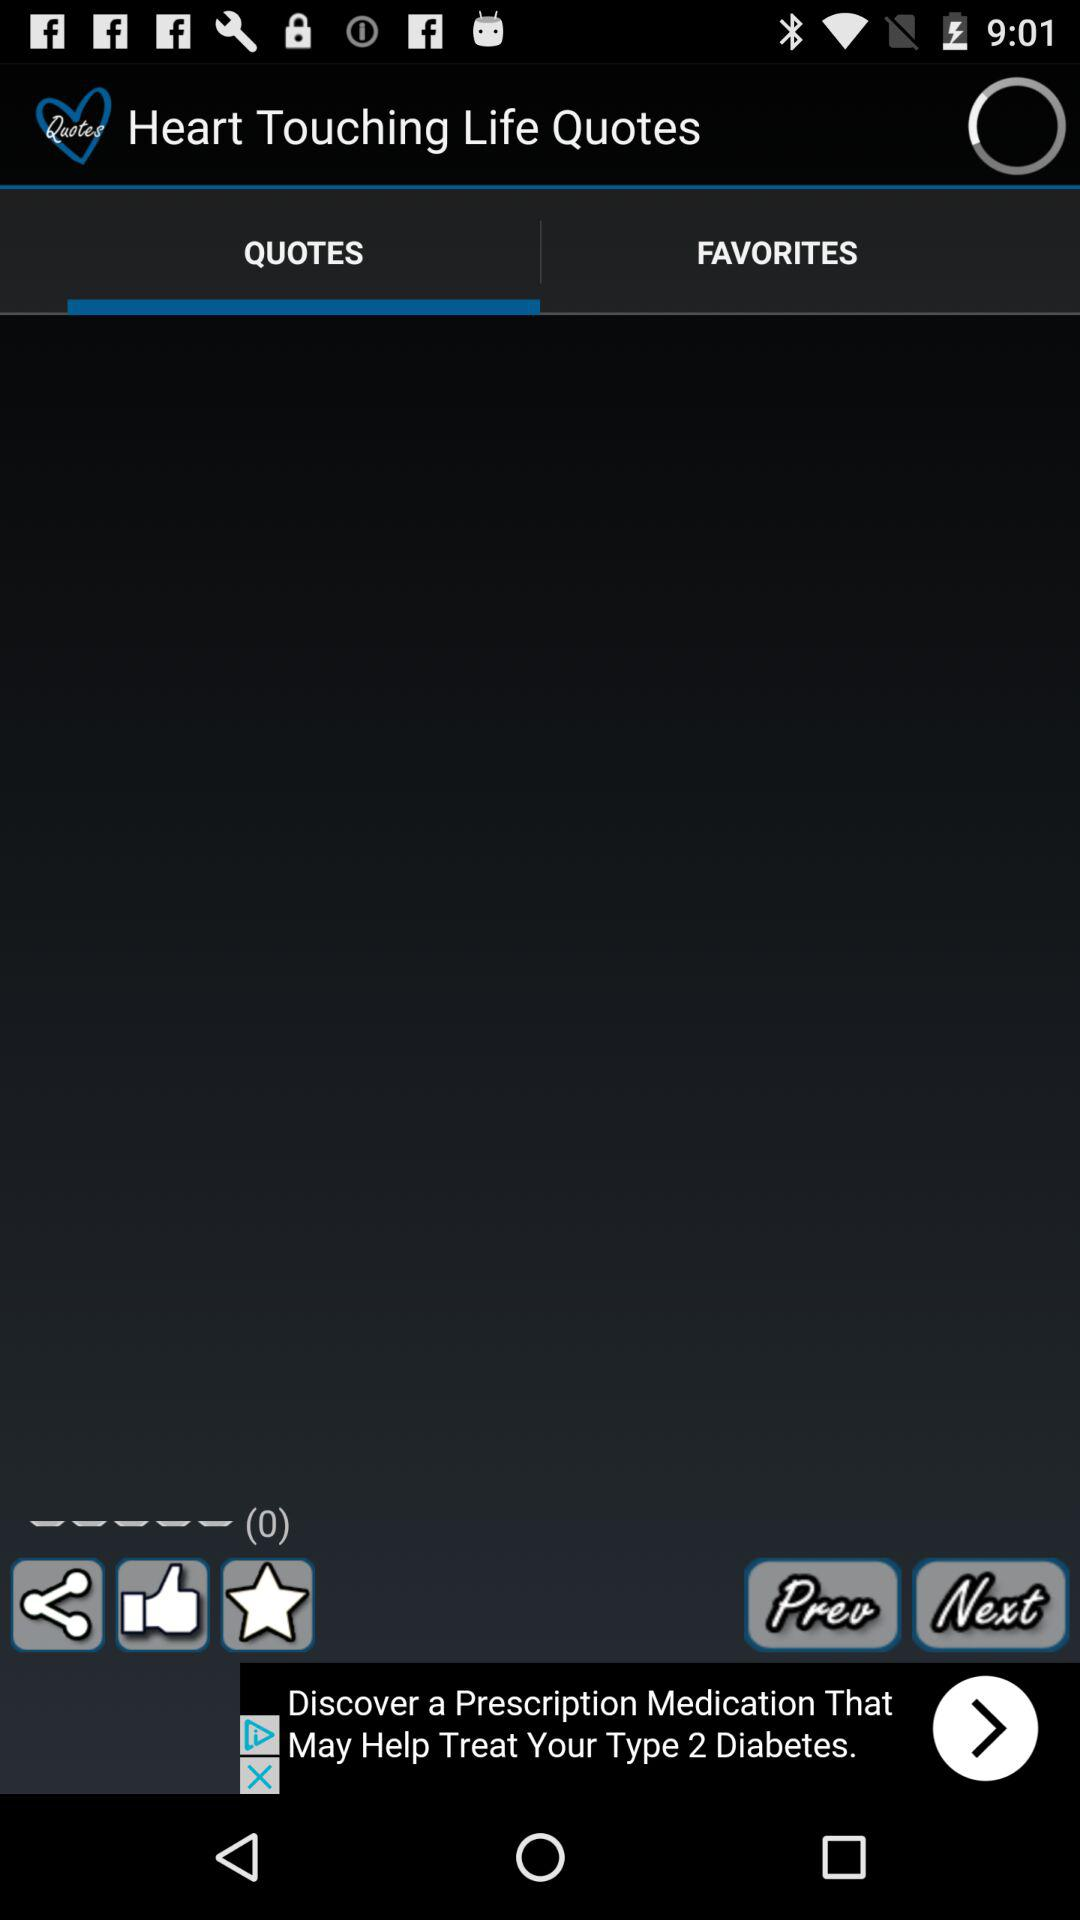Which tab is currently selected? The tab "QUOTES" is currently selected. 